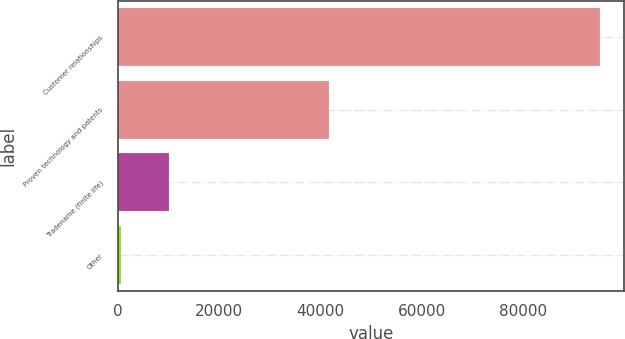Convert chart to OTSL. <chart><loc_0><loc_0><loc_500><loc_500><bar_chart><fcel>Customer relationships<fcel>Proven technology and patents<fcel>Tradename (finite life)<fcel>Other<nl><fcel>95203<fcel>41643<fcel>10189<fcel>743<nl></chart> 